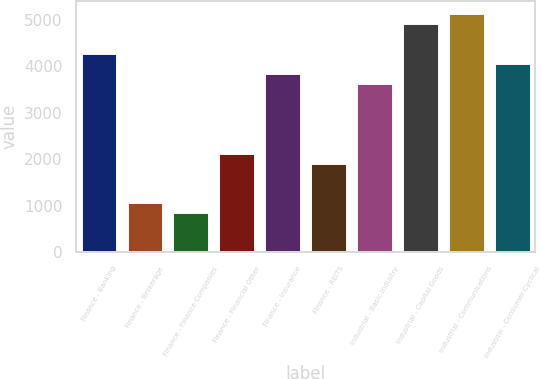Convert chart. <chart><loc_0><loc_0><loc_500><loc_500><bar_chart><fcel>Finance - Banking<fcel>Finance - Brokerage<fcel>Finance - Finance Companies<fcel>Finance - Financial Other<fcel>Finance - Insurance<fcel>Finance - REITS<fcel>Industrial - Basic Industry<fcel>Industrial - Capital Goods<fcel>Industrial - Communications<fcel>Industrial - Consumer Cyclical<nl><fcel>4282.2<fcel>1070.85<fcel>856.76<fcel>2141.3<fcel>3854.02<fcel>1927.21<fcel>3639.93<fcel>4924.47<fcel>5138.56<fcel>4068.11<nl></chart> 